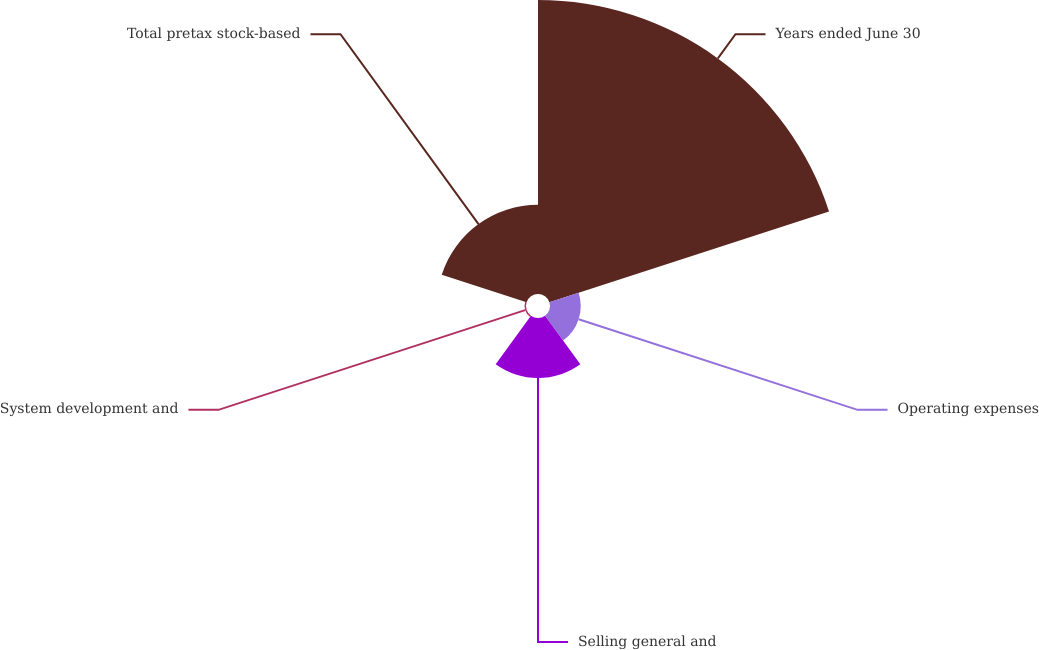Convert chart. <chart><loc_0><loc_0><loc_500><loc_500><pie_chart><fcel>Years ended June 30<fcel>Operating expenses<fcel>Selling general and<fcel>System development and<fcel>Total pretax stock-based<nl><fcel>61.85%<fcel>6.46%<fcel>12.62%<fcel>0.31%<fcel>18.77%<nl></chart> 